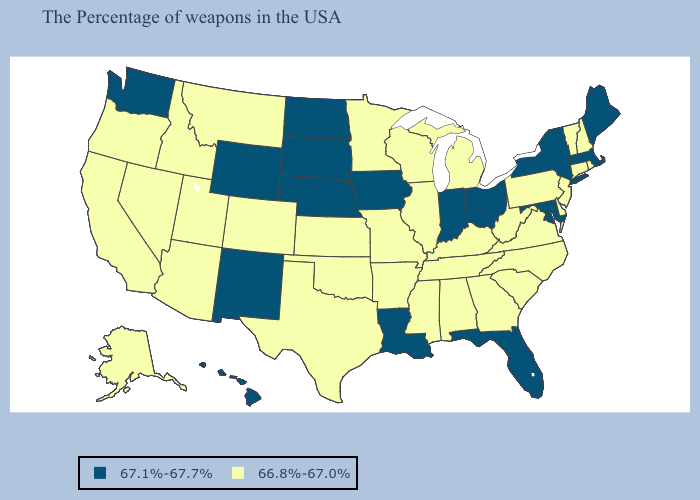Does Maine have a higher value than Idaho?
Quick response, please. Yes. Does Alabama have a higher value than New Mexico?
Write a very short answer. No. Which states have the highest value in the USA?
Be succinct. Maine, Massachusetts, New York, Maryland, Ohio, Florida, Indiana, Louisiana, Iowa, Nebraska, South Dakota, North Dakota, Wyoming, New Mexico, Washington, Hawaii. Which states have the lowest value in the Northeast?
Be succinct. Rhode Island, New Hampshire, Vermont, Connecticut, New Jersey, Pennsylvania. What is the lowest value in states that border Mississippi?
Keep it brief. 66.8%-67.0%. Among the states that border Arizona , does New Mexico have the lowest value?
Answer briefly. No. Does Virginia have the lowest value in the USA?
Give a very brief answer. Yes. Which states hav the highest value in the West?
Quick response, please. Wyoming, New Mexico, Washington, Hawaii. What is the value of Pennsylvania?
Keep it brief. 66.8%-67.0%. Name the states that have a value in the range 67.1%-67.7%?
Answer briefly. Maine, Massachusetts, New York, Maryland, Ohio, Florida, Indiana, Louisiana, Iowa, Nebraska, South Dakota, North Dakota, Wyoming, New Mexico, Washington, Hawaii. Which states have the lowest value in the MidWest?
Write a very short answer. Michigan, Wisconsin, Illinois, Missouri, Minnesota, Kansas. Name the states that have a value in the range 66.8%-67.0%?
Concise answer only. Rhode Island, New Hampshire, Vermont, Connecticut, New Jersey, Delaware, Pennsylvania, Virginia, North Carolina, South Carolina, West Virginia, Georgia, Michigan, Kentucky, Alabama, Tennessee, Wisconsin, Illinois, Mississippi, Missouri, Arkansas, Minnesota, Kansas, Oklahoma, Texas, Colorado, Utah, Montana, Arizona, Idaho, Nevada, California, Oregon, Alaska. What is the value of Georgia?
Concise answer only. 66.8%-67.0%. Name the states that have a value in the range 66.8%-67.0%?
Answer briefly. Rhode Island, New Hampshire, Vermont, Connecticut, New Jersey, Delaware, Pennsylvania, Virginia, North Carolina, South Carolina, West Virginia, Georgia, Michigan, Kentucky, Alabama, Tennessee, Wisconsin, Illinois, Mississippi, Missouri, Arkansas, Minnesota, Kansas, Oklahoma, Texas, Colorado, Utah, Montana, Arizona, Idaho, Nevada, California, Oregon, Alaska. Is the legend a continuous bar?
Concise answer only. No. 